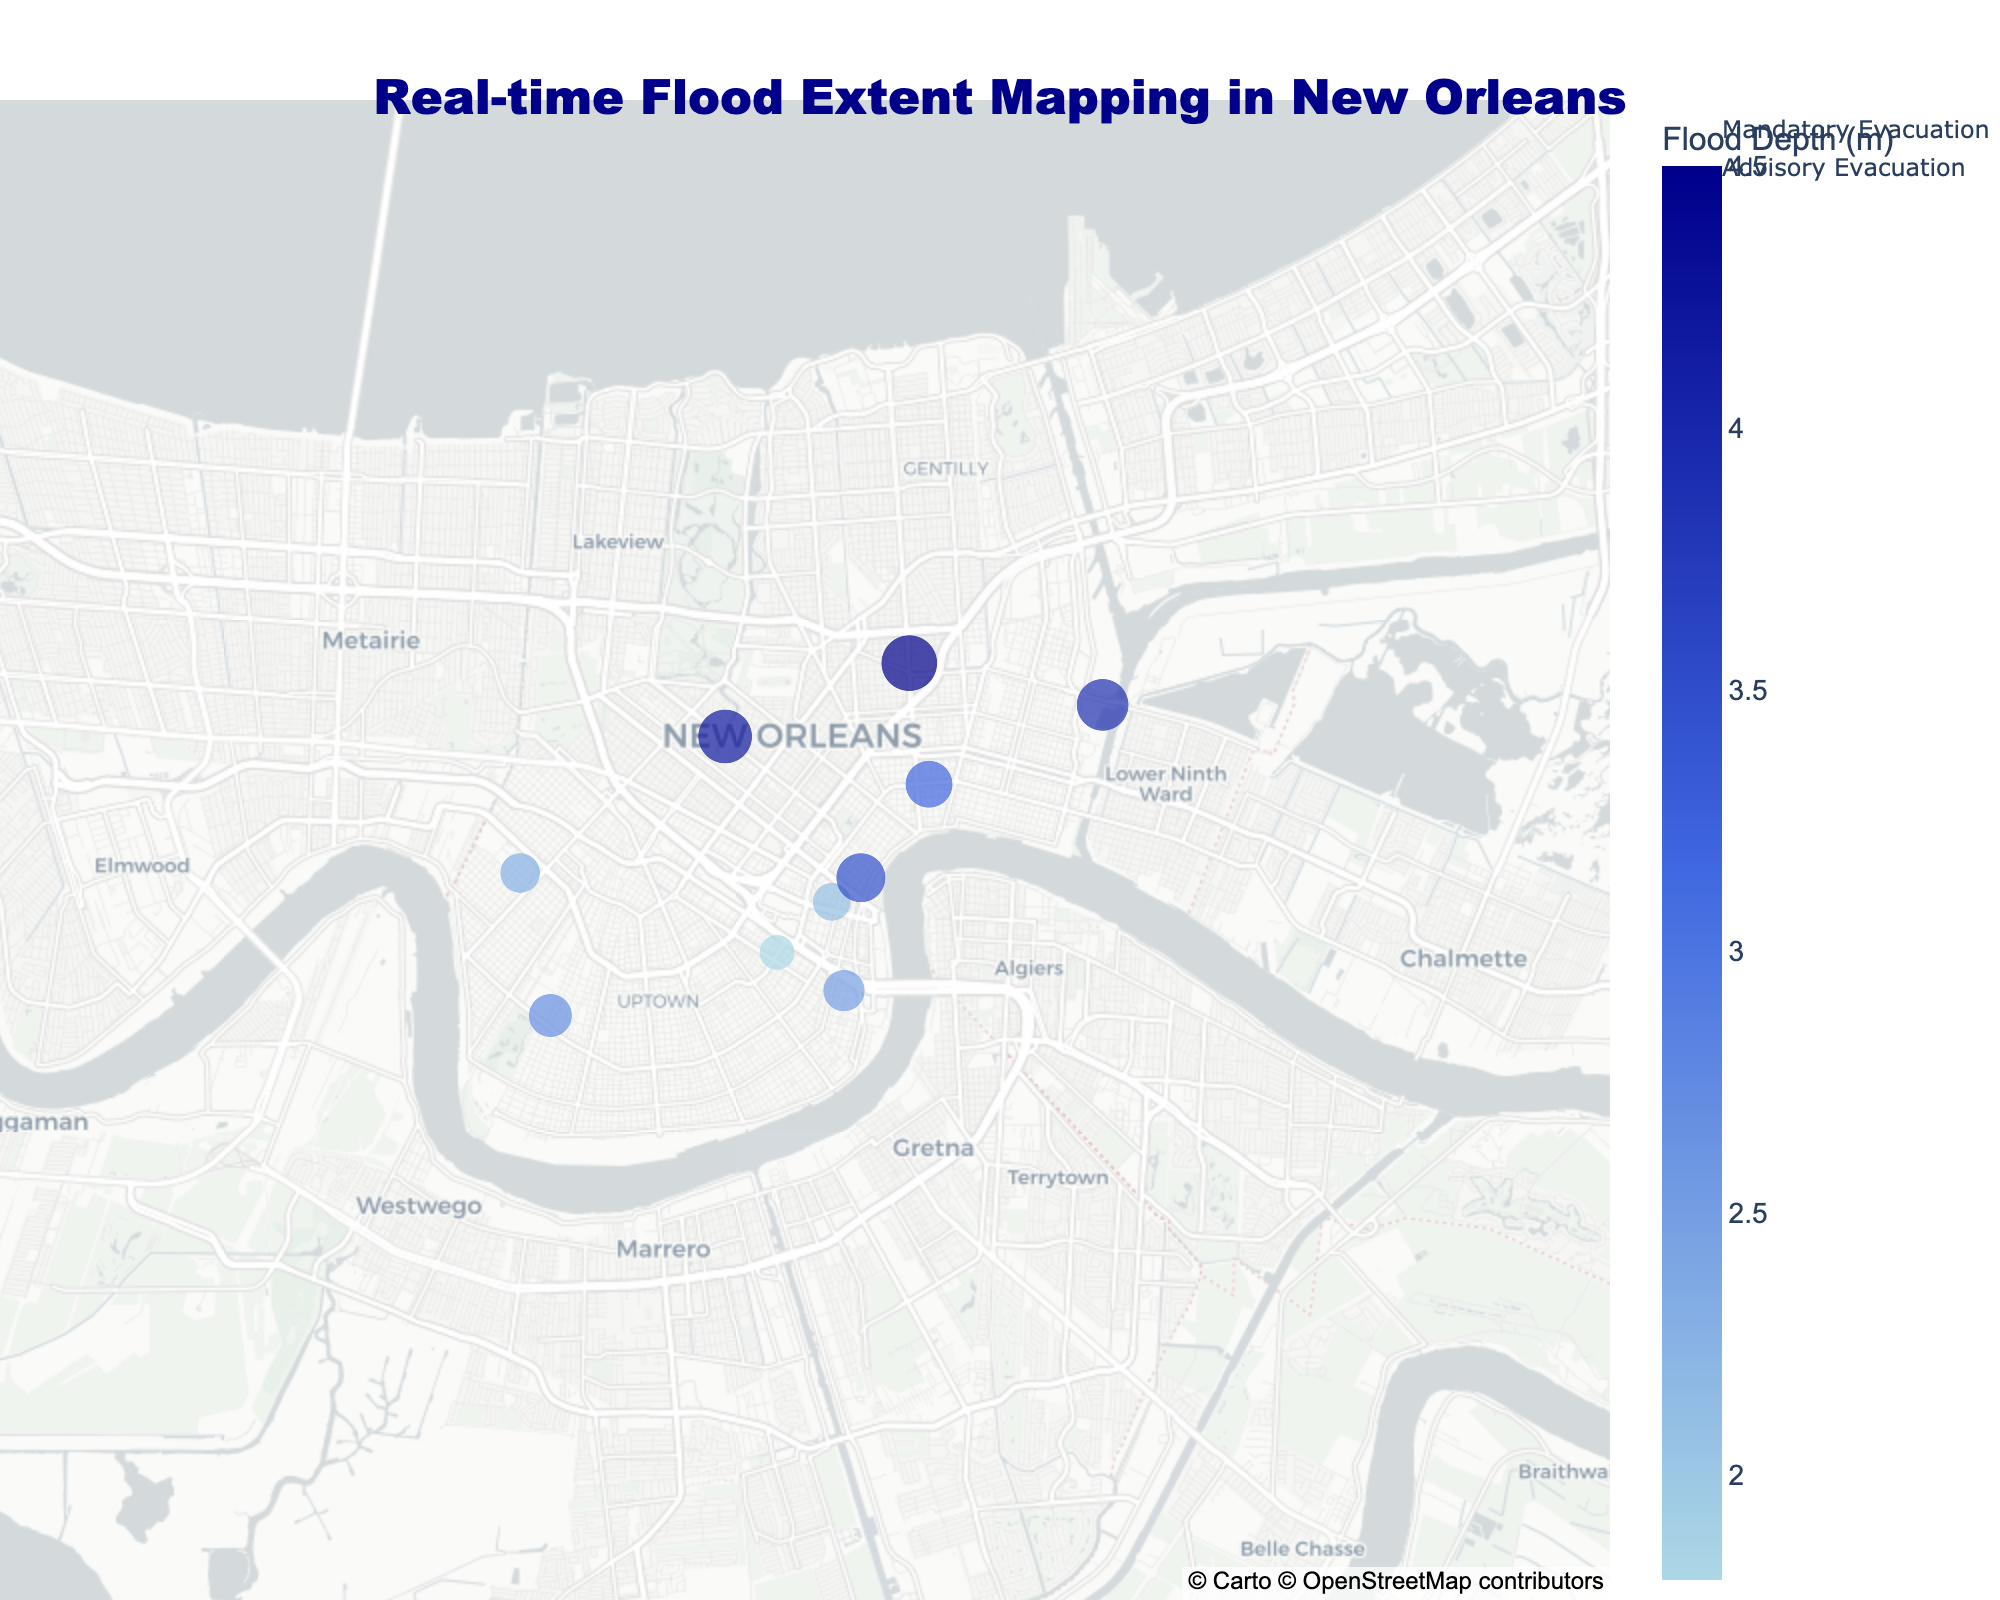What is the title of the figure? The title is prominently displayed at the top of the figure.
Answer: Real-time Flood Extent Mapping in New Orleans How many locations have a mandatory evacuation status? There are markers in red representing mandatory evacuation on the map. By counting them, it shows the total.
Answer: 5 Which location has the highest flood depth and what is it? Look for the location with the largest marker and hover over it to get additional details.
Answer: Seventh Ward, 4.5m What is the range of flood depths shown on the color bar? Observe the color axis on the side of the plot which indicates the minimum and maximum values.
Answer: 1.8 - 4.5m Which locations are currently under advisory evacuation status? Look for orange markers on the map and check the corresponding locations.
Answer: French Quarter, Garden District, Uptown, Central Business District, Carrollton What is the average flood depth across all locations? Add all the flood depth values and divide by the number of locations (average = (2.1 + 3.5 + 1.8 + 4.2 + 2.7 + 3.9 + 3.2 + 2.5 + 4.5 + 2.3) / 10).
Answer: 3.07m Which location reported the first flooding event and at what time? Refer to the earliest timestamp in the hover details.
Answer: French Quarter, 2023-09-15 14:30:00 Are there more locations with advisory evacuation or mandatory evacuation? Compare the number of orange markers (advisory) and red markers (mandatory).
Answer: Advisory evacuation Which location has the lowest flood depth and what is it? Find the smallest marker on the map and hover over it for additional details.
Answer: Garden District, 1.8m What is the color used to represent the highest flood depth on the map? Observe the color bar and the shade for the highest value.
Answer: Dark blue 